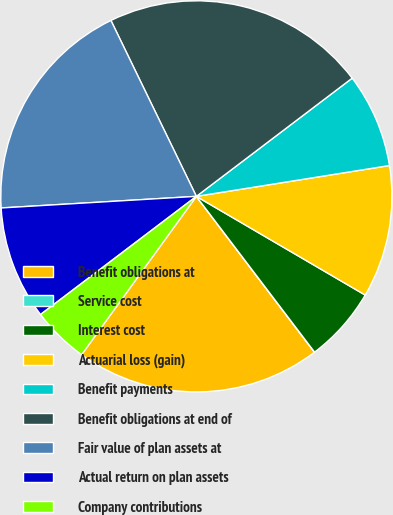Convert chart. <chart><loc_0><loc_0><loc_500><loc_500><pie_chart><fcel>Benefit obligations at<fcel>Service cost<fcel>Interest cost<fcel>Actuarial loss (gain)<fcel>Benefit payments<fcel>Benefit obligations at end of<fcel>Fair value of plan assets at<fcel>Actual return on plan assets<fcel>Company contributions<nl><fcel>20.31%<fcel>0.01%<fcel>6.25%<fcel>10.94%<fcel>7.81%<fcel>21.87%<fcel>18.75%<fcel>9.38%<fcel>4.69%<nl></chart> 